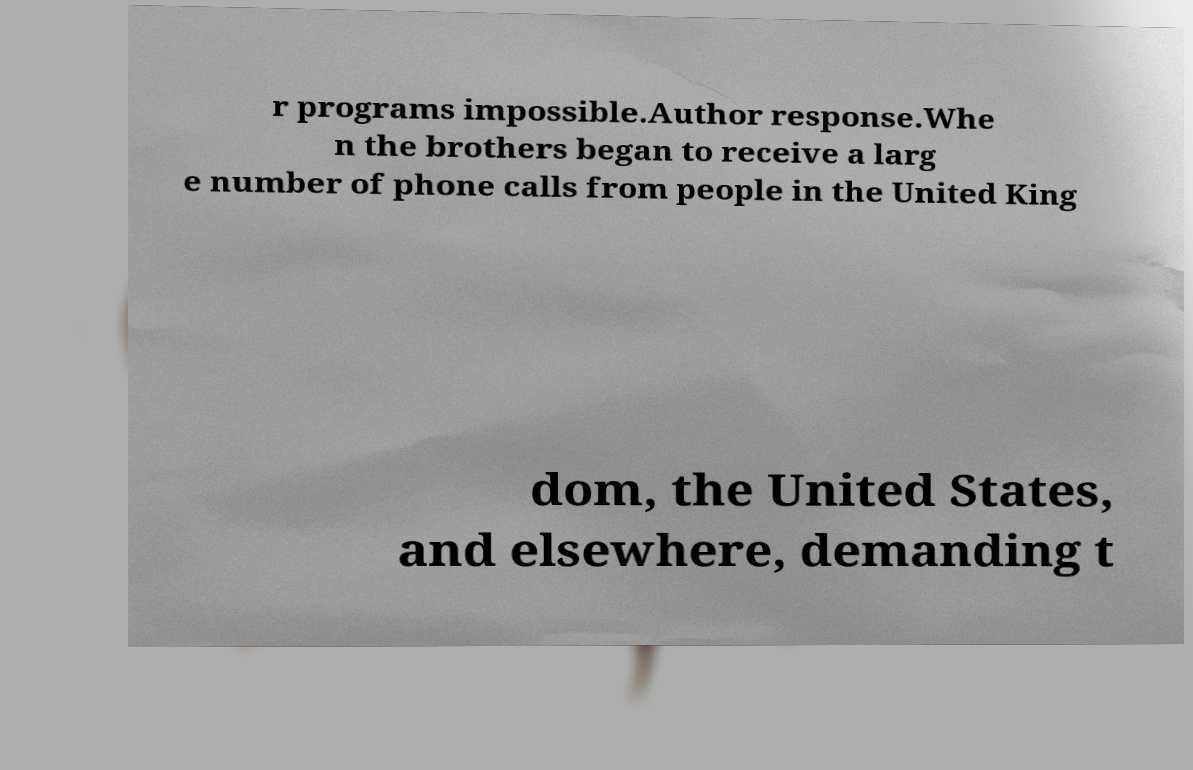Can you accurately transcribe the text from the provided image for me? r programs impossible.Author response.Whe n the brothers began to receive a larg e number of phone calls from people in the United King dom, the United States, and elsewhere, demanding t 